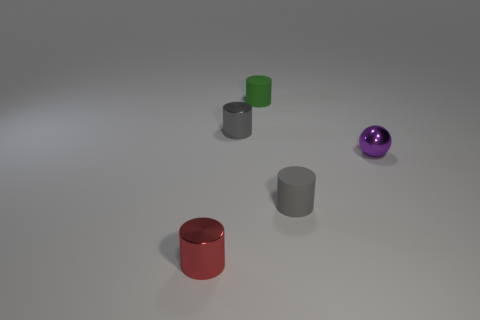If I were to categorize these objects by materials, what categories would you suggest? Based on their appearance in the image, the objects could be categorized into 'matte' for the non-shiny cylinders and cube, and 'metallic' or 'shiny' for the purple sphere, which reflects light as if it has a glossy surface. 